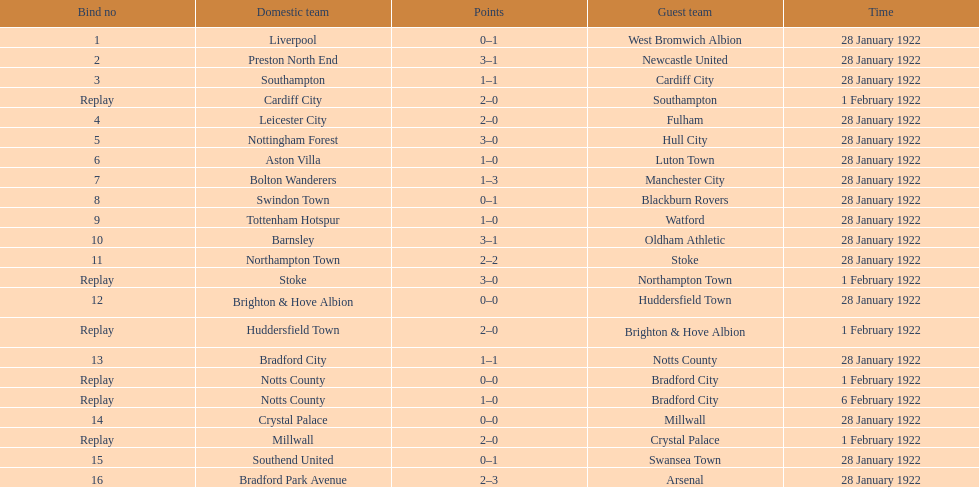What was the date of their performance before february 1? 28 January 1922. 